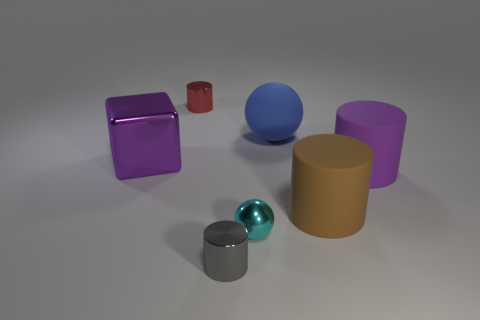Add 3 large blue rubber spheres. How many objects exist? 10 Subtract all brown cylinders. How many cylinders are left? 3 Subtract all cylinders. How many objects are left? 3 Subtract all cyan spheres. How many spheres are left? 1 Subtract 0 cyan cylinders. How many objects are left? 7 Subtract 1 cylinders. How many cylinders are left? 3 Subtract all yellow blocks. Subtract all cyan balls. How many blocks are left? 1 Subtract all matte balls. Subtract all tiny gray cylinders. How many objects are left? 5 Add 6 small metal objects. How many small metal objects are left? 9 Add 7 yellow metallic things. How many yellow metallic things exist? 7 